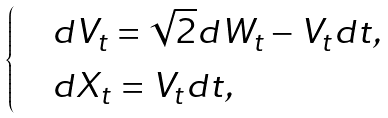Convert formula to latex. <formula><loc_0><loc_0><loc_500><loc_500>\begin{cases} & d V _ { t } = \sqrt { 2 } d W _ { t } - V _ { t } d t , \\ & d X _ { t } = V _ { t } d t , \end{cases}</formula> 